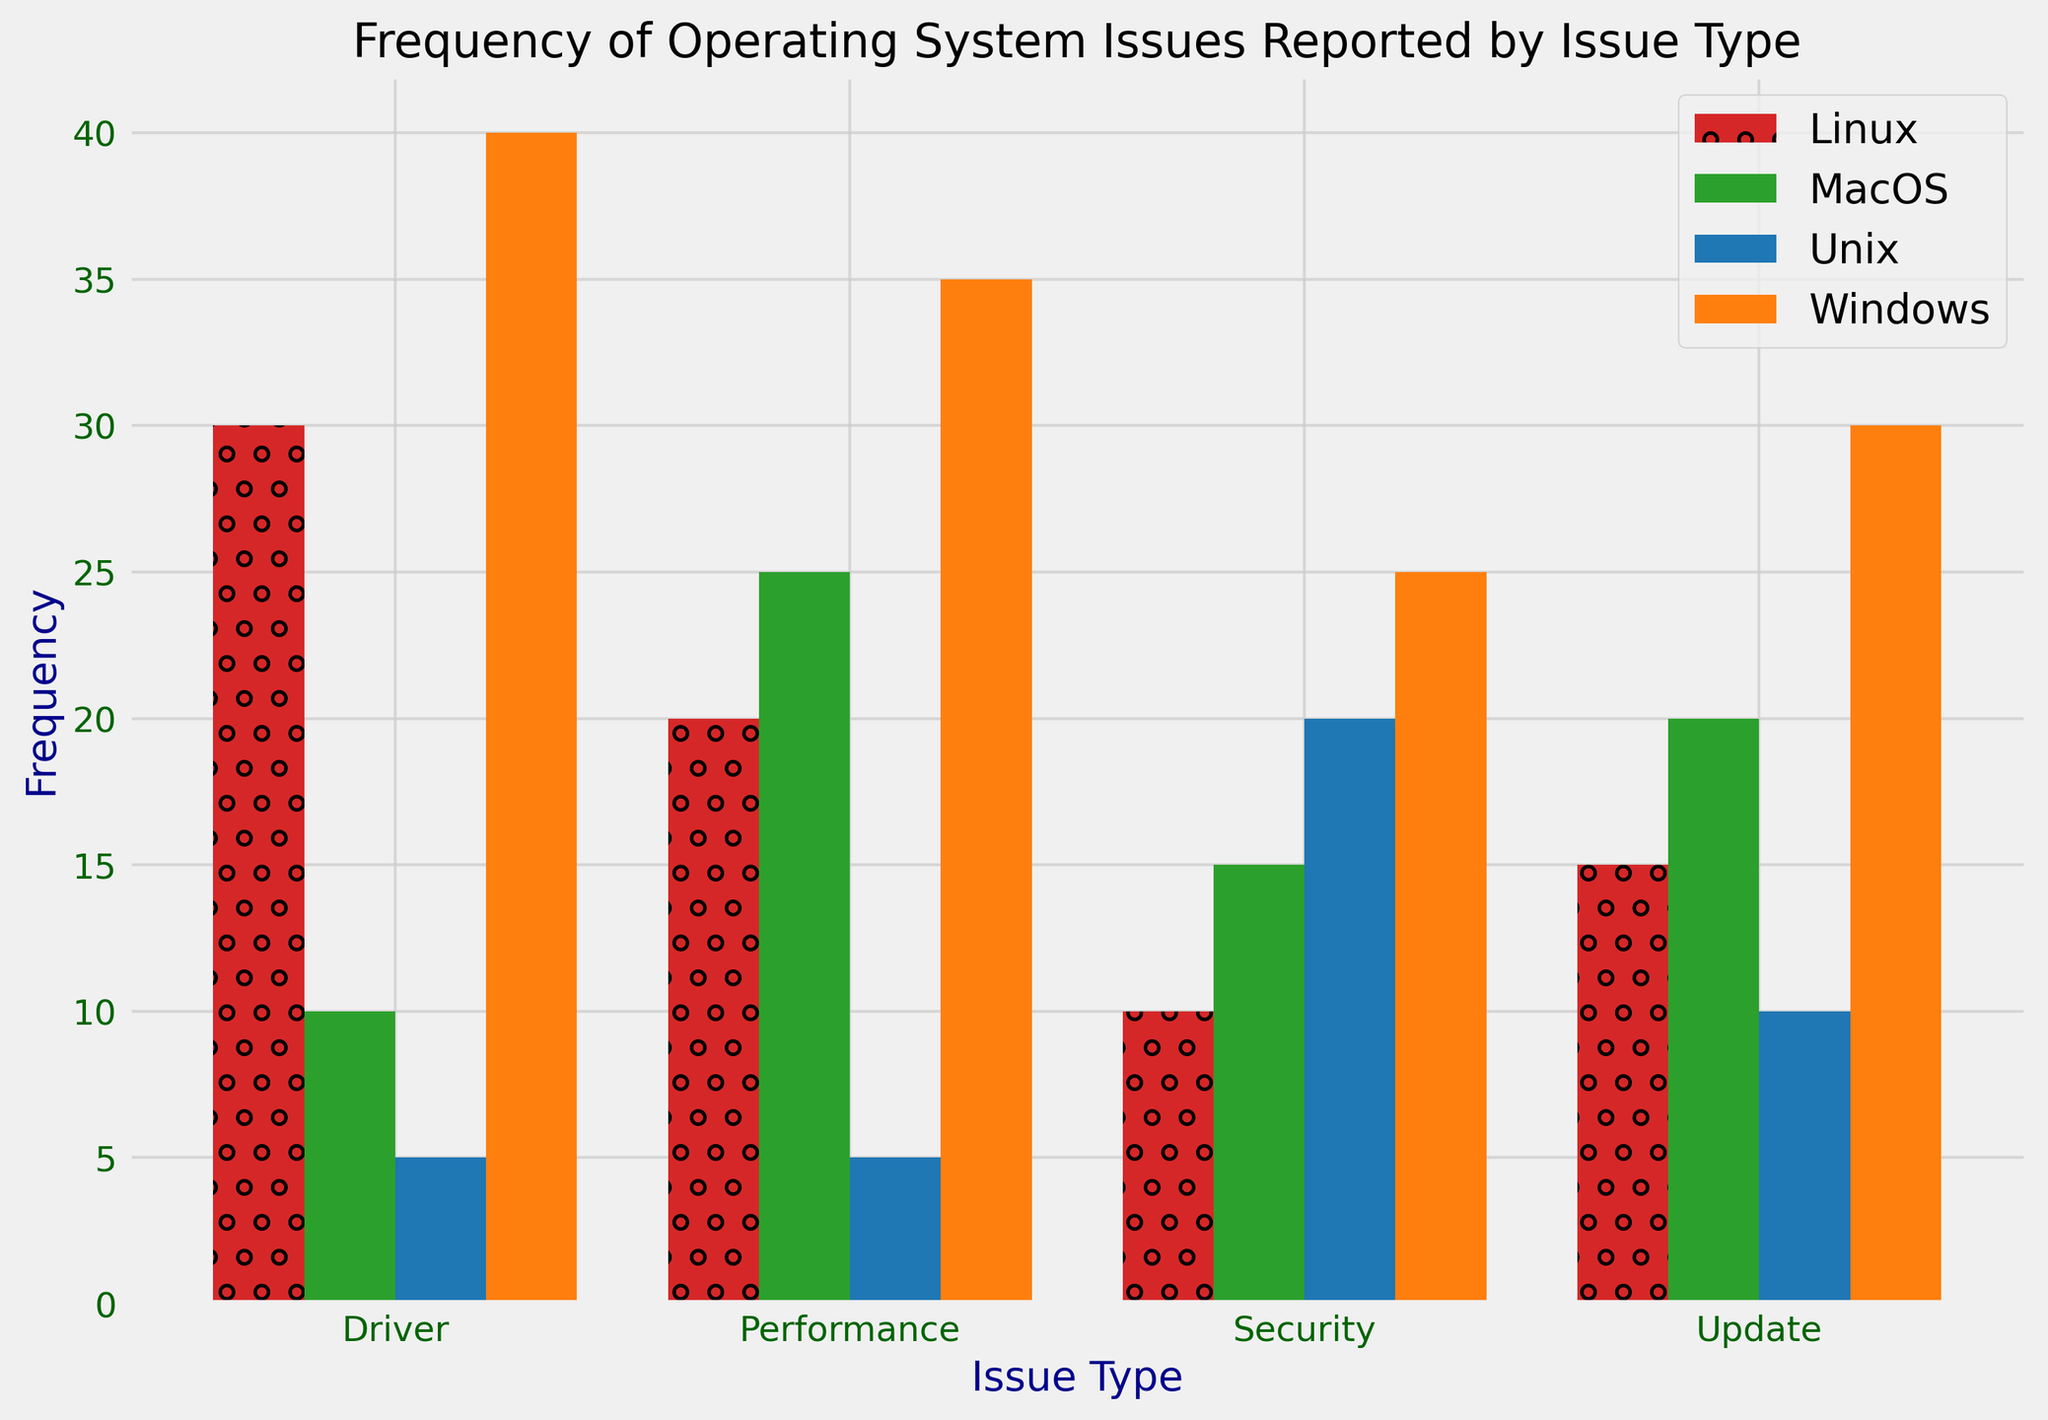How many total issues were reported for Windows and MacOS combined? First, sum the frequencies of issues reported for Windows (40 + 30 + 25 + 35 = 130). Then, sum the frequencies for MacOS (10 + 20 + 15 + 25 = 70). Finally, add these two sums together (130 + 70 = 200).
Answer: 200 Which operating system has the highest frequency of driver issues? By inspecting the heights of the bars for driver issues, we see that Windows has the highest bar with a frequency of 40.
Answer: Windows What is the difference in frequency of performance issues between Windows and Unix? The frequency of performance issues reported for Windows is 35, while for Unix it is 5. The difference is calculated as 35 - 5 = 30.
Answer: 30 Which issue type is most frequently reported for MacOS? By looking at the height of the bars for MacOS across different issue types, Performance has the highest bar with a frequency of 25.
Answer: Performance Between Linux and Unix, which one has a higher overall frequency of issues? Sum the frequencies of issues reported for Linux (30 + 15 + 10 + 20 = 75) and for Unix (5 + 10 + 20 + 5 = 40). Since 75 > 40, Linux has a higher overall frequency of issues.
Answer: Linux What is the average frequency of update issues across all operating systems? Sum the frequencies of update issues (30 for Windows, 20 for MacOS, 15 for Linux, and 10 for Unix). The total sum is 30 + 20 + 15 + 10 = 75. The average is then 75 / 4 = 18.75.
Answer: 18.75 For which issue type is the total frequency across all operating systems the highest? Calculate the total frequencies for each issue type: Driver (40 + 10 + 30 + 5 = 85), Update (30 + 20 + 15 + 10 = 75), Security (25 + 15 + 10 + 20 = 70), Performance (35 + 25 + 20 + 5 = 85). Driver and Performance both have the highest total frequency of 85.
Answer: Driver and Performance How does the frequency of security issues in Unix compare to Linux? The frequency of security issues is 20 in Unix and 10 in Linux. Unix has a higher frequency of security issues than Linux.
Answer: Unix has higher frequency What is the sum of the frequencies of driver and update issues for Windows? Sum the frequencies of driver issues (40) and update issues (30) for Windows. The total sum is 40 + 30 = 70.
Answer: 70 Which operating system has the least frequency of overall issues? Calculate the total frequencies for each operating system: Windows (130), MacOS (70), Linux (75), Unix (40). Unix has the least total frequency with 40.
Answer: Unix 